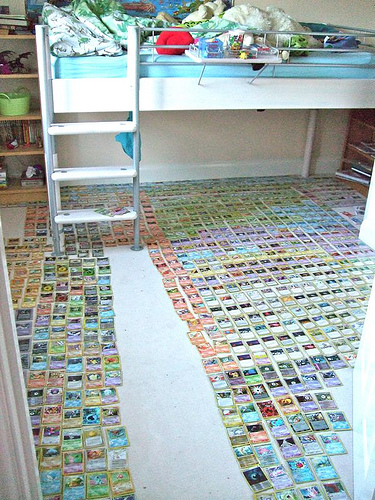<image>
Can you confirm if the pokemon cards is under the bed? Yes. The pokemon cards is positioned underneath the bed, with the bed above it in the vertical space. Is there a blanket under the mattress? No. The blanket is not positioned under the mattress. The vertical relationship between these objects is different. 